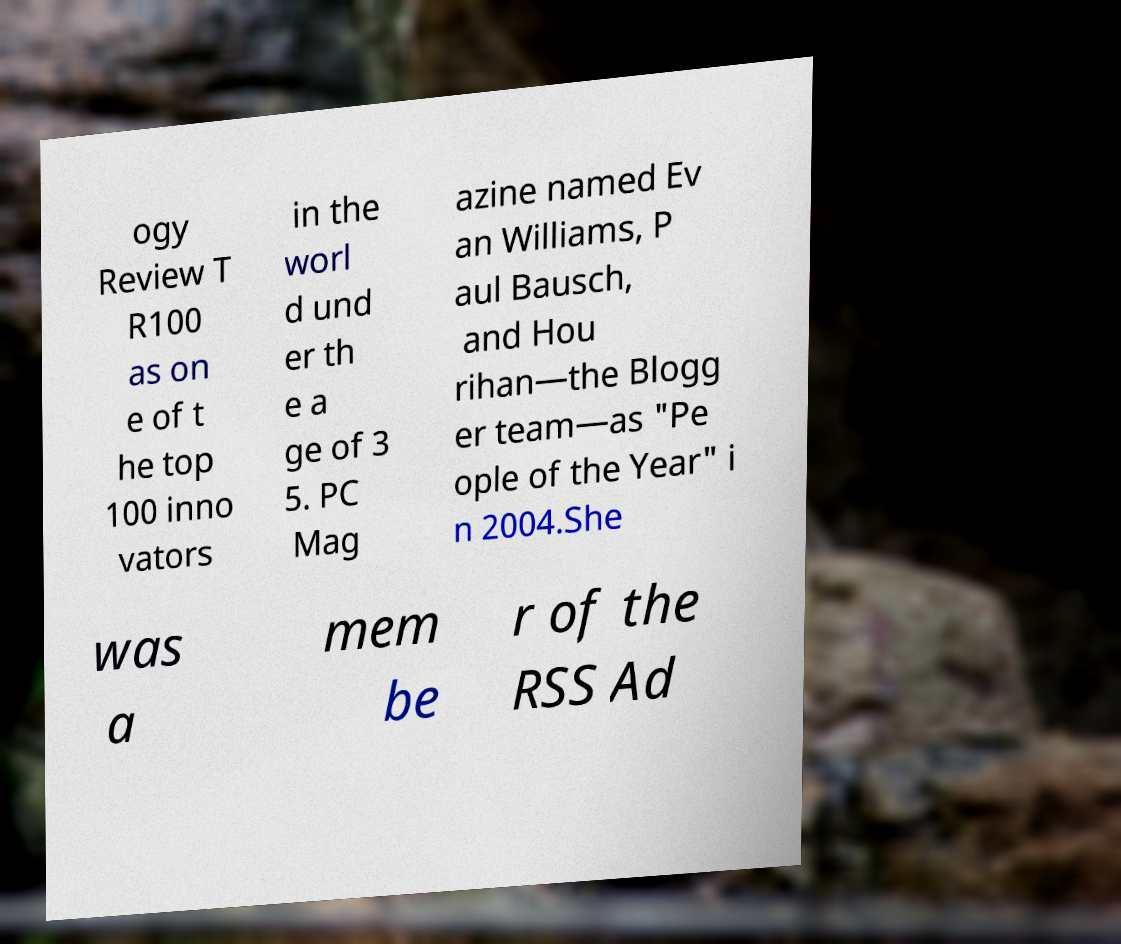Could you extract and type out the text from this image? ogy Review T R100 as on e of t he top 100 inno vators in the worl d und er th e a ge of 3 5. PC Mag azine named Ev an Williams, P aul Bausch, and Hou rihan—the Blogg er team—as "Pe ople of the Year" i n 2004.She was a mem be r of the RSS Ad 